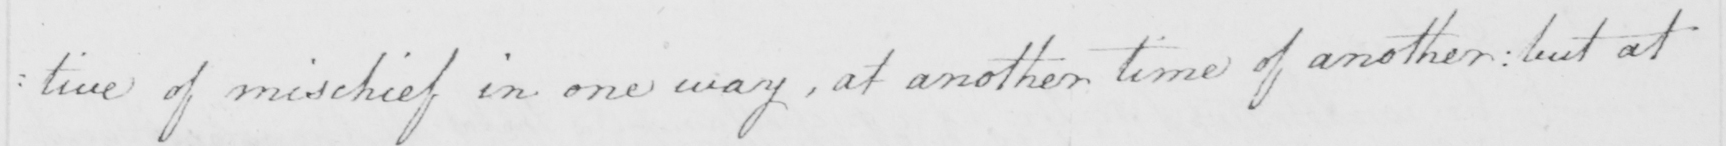What is written in this line of handwriting? : tive of mischief in one way , at another time of another :  but at 